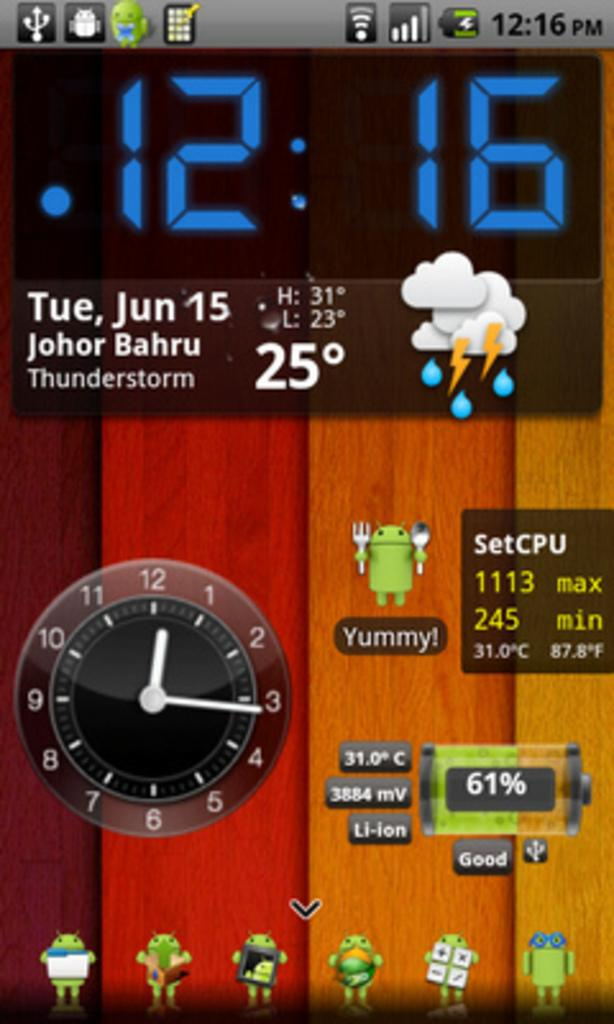<image>
Give a short and clear explanation of the subsequent image. A phone homescreen says that thunderstorms are in the forecast. 